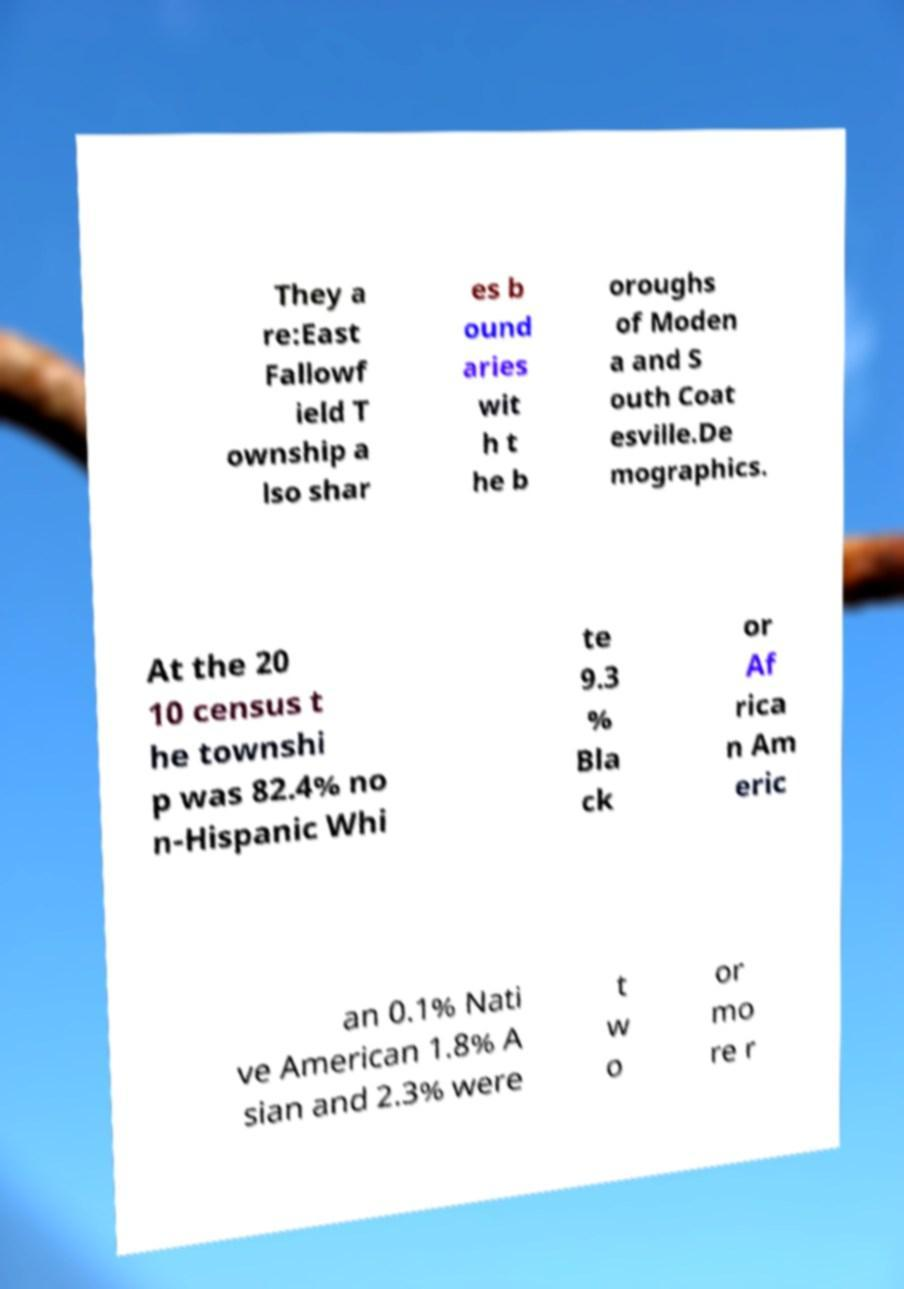What messages or text are displayed in this image? I need them in a readable, typed format. They a re:East Fallowf ield T ownship a lso shar es b ound aries wit h t he b oroughs of Moden a and S outh Coat esville.De mographics. At the 20 10 census t he townshi p was 82.4% no n-Hispanic Whi te 9.3 % Bla ck or Af rica n Am eric an 0.1% Nati ve American 1.8% A sian and 2.3% were t w o or mo re r 